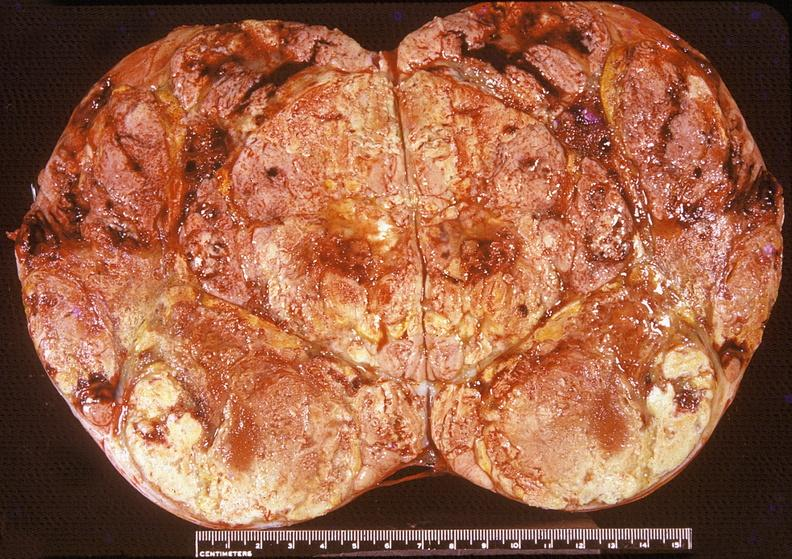what is present?
Answer the question using a single word or phrase. Endocrine 